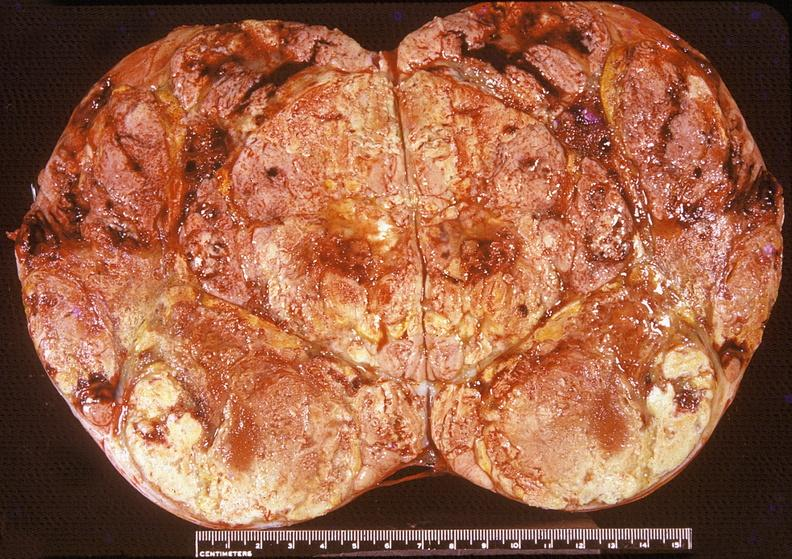what is present?
Answer the question using a single word or phrase. Endocrine 